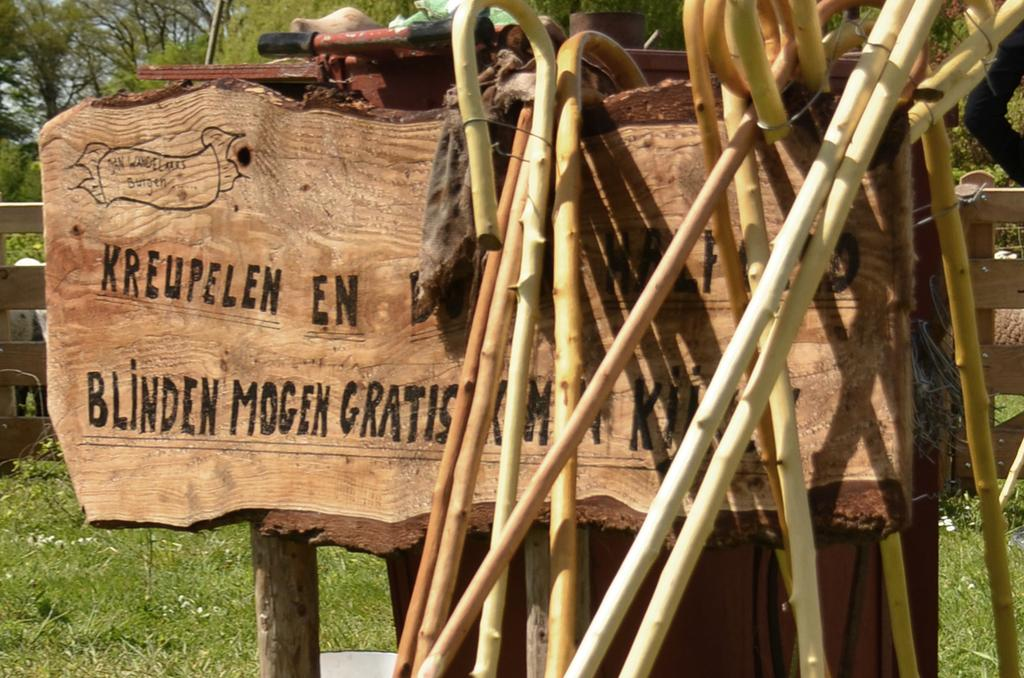What is the main object in the image? There is a wooden board in the image. What is placed on the wooden board? Wooden sticks are laid on the wooden board. What type of natural environment is depicted in the image? There is a lot of grass and many trees in the image. How many ants can be seen carrying toothpaste in the image? There are no ants or toothpaste present in the image. What unit of measurement is used to determine the size of the wooden board in the image? The provided facts do not mention any specific unit of measurement for the wooden board. 